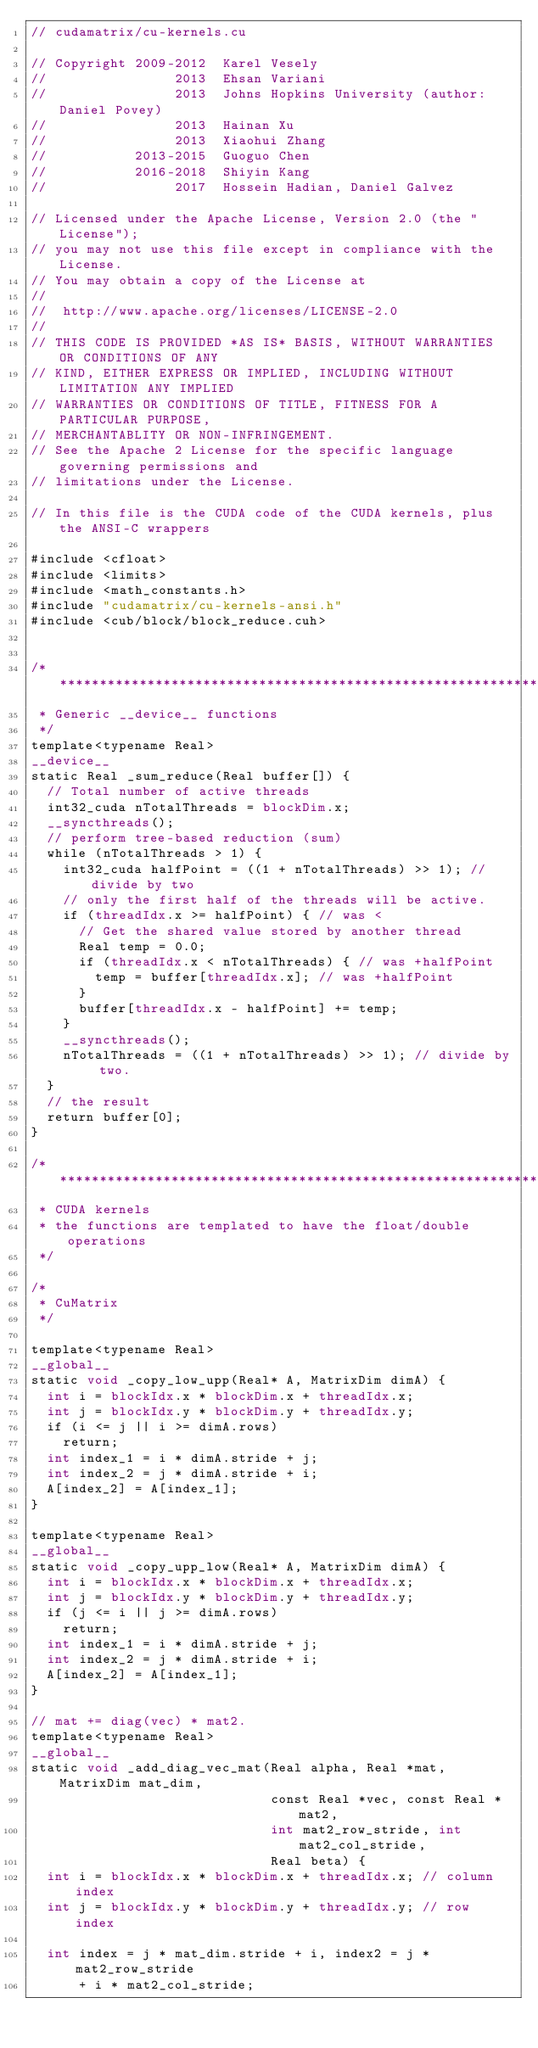<code> <loc_0><loc_0><loc_500><loc_500><_Cuda_>// cudamatrix/cu-kernels.cu

// Copyright 2009-2012  Karel Vesely
//                2013  Ehsan Variani
//                2013  Johns Hopkins University (author: Daniel Povey)
//                2013  Hainan Xu
//                2013  Xiaohui Zhang
//           2013-2015  Guoguo Chen
//           2016-2018  Shiyin Kang
//                2017  Hossein Hadian, Daniel Galvez

// Licensed under the Apache License, Version 2.0 (the "License");
// you may not use this file except in compliance with the License.
// You may obtain a copy of the License at
//
//  http://www.apache.org/licenses/LICENSE-2.0
//
// THIS CODE IS PROVIDED *AS IS* BASIS, WITHOUT WARRANTIES OR CONDITIONS OF ANY
// KIND, EITHER EXPRESS OR IMPLIED, INCLUDING WITHOUT LIMITATION ANY IMPLIED
// WARRANTIES OR CONDITIONS OF TITLE, FITNESS FOR A PARTICULAR PURPOSE,
// MERCHANTABLITY OR NON-INFRINGEMENT.
// See the Apache 2 License for the specific language governing permissions and
// limitations under the License.

// In this file is the CUDA code of the CUDA kernels, plus the ANSI-C wrappers

#include <cfloat>
#include <limits>
#include <math_constants.h>
#include "cudamatrix/cu-kernels-ansi.h"
#include <cub/block/block_reduce.cuh>


/***********************************************************************
 * Generic __device__ functions
 */
template<typename Real>
__device__
static Real _sum_reduce(Real buffer[]) {
  // Total number of active threads
  int32_cuda nTotalThreads = blockDim.x;
  __syncthreads();
  // perform tree-based reduction (sum)
  while (nTotalThreads > 1) {
    int32_cuda halfPoint = ((1 + nTotalThreads) >> 1); // divide by two
    // only the first half of the threads will be active.
    if (threadIdx.x >= halfPoint) { // was <
      // Get the shared value stored by another thread
      Real temp = 0.0;
      if (threadIdx.x < nTotalThreads) { // was +halfPoint
        temp = buffer[threadIdx.x]; // was +halfPoint
      }
      buffer[threadIdx.x - halfPoint] += temp;
    }
    __syncthreads();
    nTotalThreads = ((1 + nTotalThreads) >> 1); // divide by two.
  }
  // the result
  return buffer[0];
}

/***********************************************************************
 * CUDA kernels
 * the functions are templated to have the float/double operations
 */

/*
 * CuMatrix
 */

template<typename Real>
__global__
static void _copy_low_upp(Real* A, MatrixDim dimA) {
  int i = blockIdx.x * blockDim.x + threadIdx.x;
  int j = blockIdx.y * blockDim.y + threadIdx.y;
  if (i <= j || i >= dimA.rows)
    return;
  int index_1 = i * dimA.stride + j;
  int index_2 = j * dimA.stride + i;
  A[index_2] = A[index_1];
}

template<typename Real>
__global__
static void _copy_upp_low(Real* A, MatrixDim dimA) {
  int i = blockIdx.x * blockDim.x + threadIdx.x;
  int j = blockIdx.y * blockDim.y + threadIdx.y;
  if (j <= i || j >= dimA.rows)
    return;
  int index_1 = i * dimA.stride + j;
  int index_2 = j * dimA.stride + i;
  A[index_2] = A[index_1];
}

// mat += diag(vec) * mat2.
template<typename Real>
__global__
static void _add_diag_vec_mat(Real alpha, Real *mat, MatrixDim mat_dim,
                              const Real *vec, const Real *mat2,
                              int mat2_row_stride, int mat2_col_stride,
                              Real beta) {
  int i = blockIdx.x * blockDim.x + threadIdx.x; // column index
  int j = blockIdx.y * blockDim.y + threadIdx.y; // row index

  int index = j * mat_dim.stride + i, index2 = j * mat2_row_stride
      + i * mat2_col_stride;
</code> 